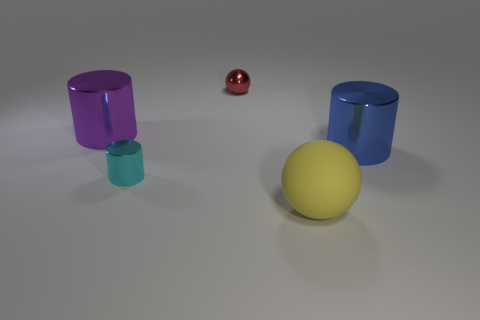Are there any large purple things that have the same shape as the red metallic object?
Your answer should be very brief. No. There is a shiny object that is both right of the tiny cyan object and behind the large blue cylinder; what is its shape?
Offer a terse response. Sphere. Is the large sphere made of the same material as the large cylinder right of the tiny red object?
Your answer should be compact. No. Are there any rubber balls right of the yellow ball?
Ensure brevity in your answer.  No. What number of objects are purple rubber objects or big shiny things that are left of the small red shiny thing?
Offer a terse response. 1. There is a sphere that is behind the tiny thing that is in front of the big blue thing; what color is it?
Your answer should be very brief. Red. What number of other objects are there of the same material as the small red ball?
Ensure brevity in your answer.  3. How many metal objects are yellow spheres or large things?
Keep it short and to the point. 2. What is the color of the tiny object that is the same shape as the big purple shiny thing?
Provide a short and direct response. Cyan. How many things are either gray matte spheres or small metallic things?
Your response must be concise. 2. 